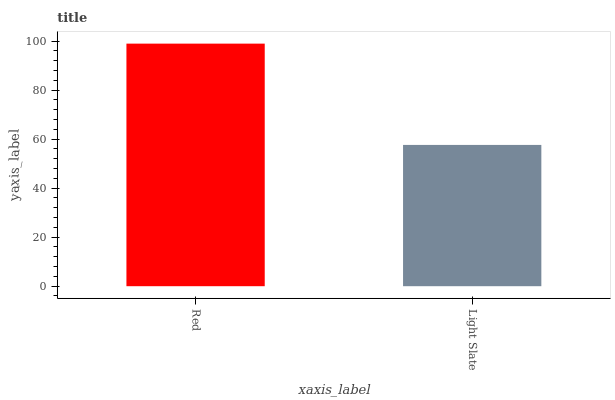Is Light Slate the minimum?
Answer yes or no. Yes. Is Red the maximum?
Answer yes or no. Yes. Is Light Slate the maximum?
Answer yes or no. No. Is Red greater than Light Slate?
Answer yes or no. Yes. Is Light Slate less than Red?
Answer yes or no. Yes. Is Light Slate greater than Red?
Answer yes or no. No. Is Red less than Light Slate?
Answer yes or no. No. Is Red the high median?
Answer yes or no. Yes. Is Light Slate the low median?
Answer yes or no. Yes. Is Light Slate the high median?
Answer yes or no. No. Is Red the low median?
Answer yes or no. No. 